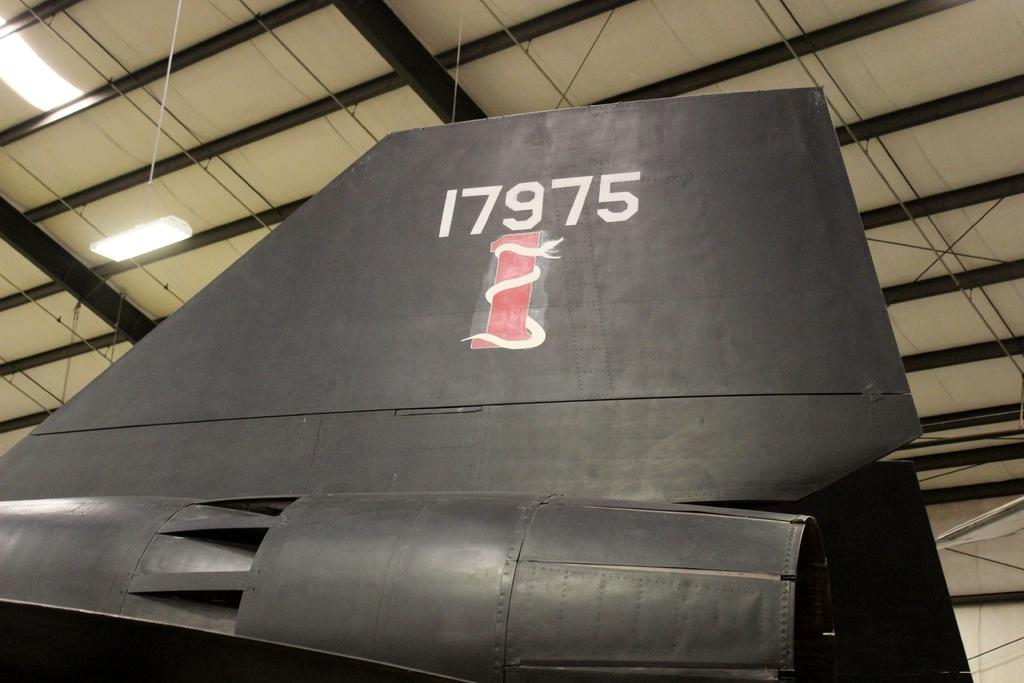<image>
Render a clear and concise summary of the photo. The rudder to a jet with the numbers 17975 printed on it. 